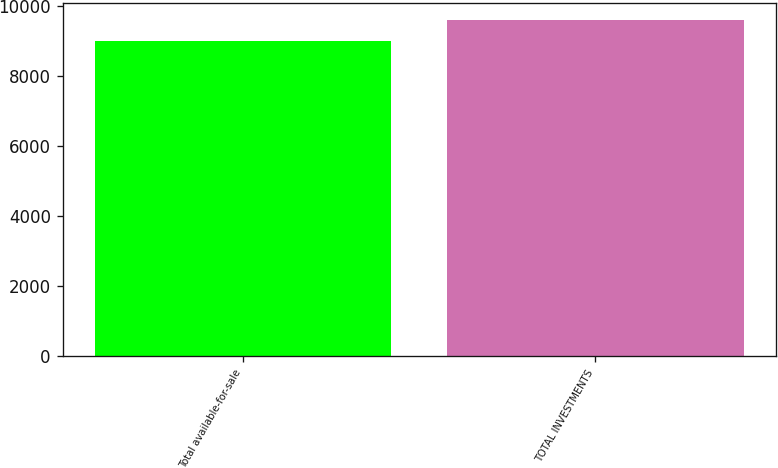Convert chart to OTSL. <chart><loc_0><loc_0><loc_500><loc_500><bar_chart><fcel>Total available-for-sale<fcel>TOTAL INVESTMENTS<nl><fcel>9008<fcel>9597<nl></chart> 